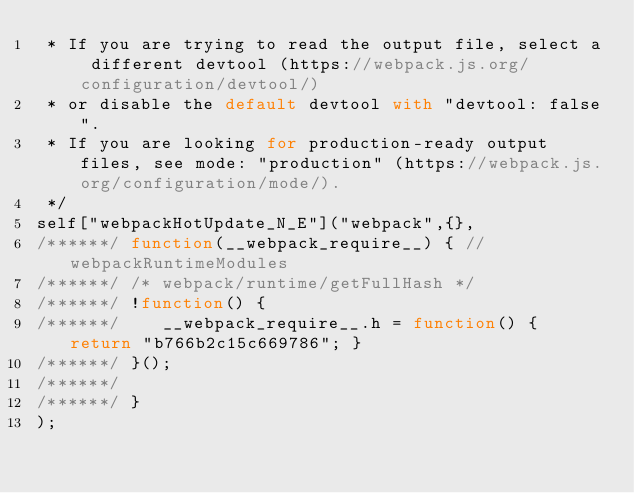<code> <loc_0><loc_0><loc_500><loc_500><_JavaScript_> * If you are trying to read the output file, select a different devtool (https://webpack.js.org/configuration/devtool/)
 * or disable the default devtool with "devtool: false".
 * If you are looking for production-ready output files, see mode: "production" (https://webpack.js.org/configuration/mode/).
 */
self["webpackHotUpdate_N_E"]("webpack",{},
/******/ function(__webpack_require__) { // webpackRuntimeModules
/******/ /* webpack/runtime/getFullHash */
/******/ !function() {
/******/ 	__webpack_require__.h = function() { return "b766b2c15c669786"; }
/******/ }();
/******/ 
/******/ }
);</code> 